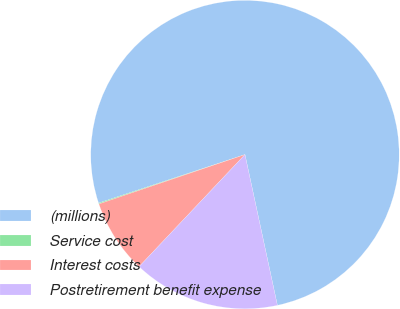<chart> <loc_0><loc_0><loc_500><loc_500><pie_chart><fcel>(millions)<fcel>Service cost<fcel>Interest costs<fcel>Postretirement benefit expense<nl><fcel>76.71%<fcel>0.1%<fcel>7.76%<fcel>15.42%<nl></chart> 